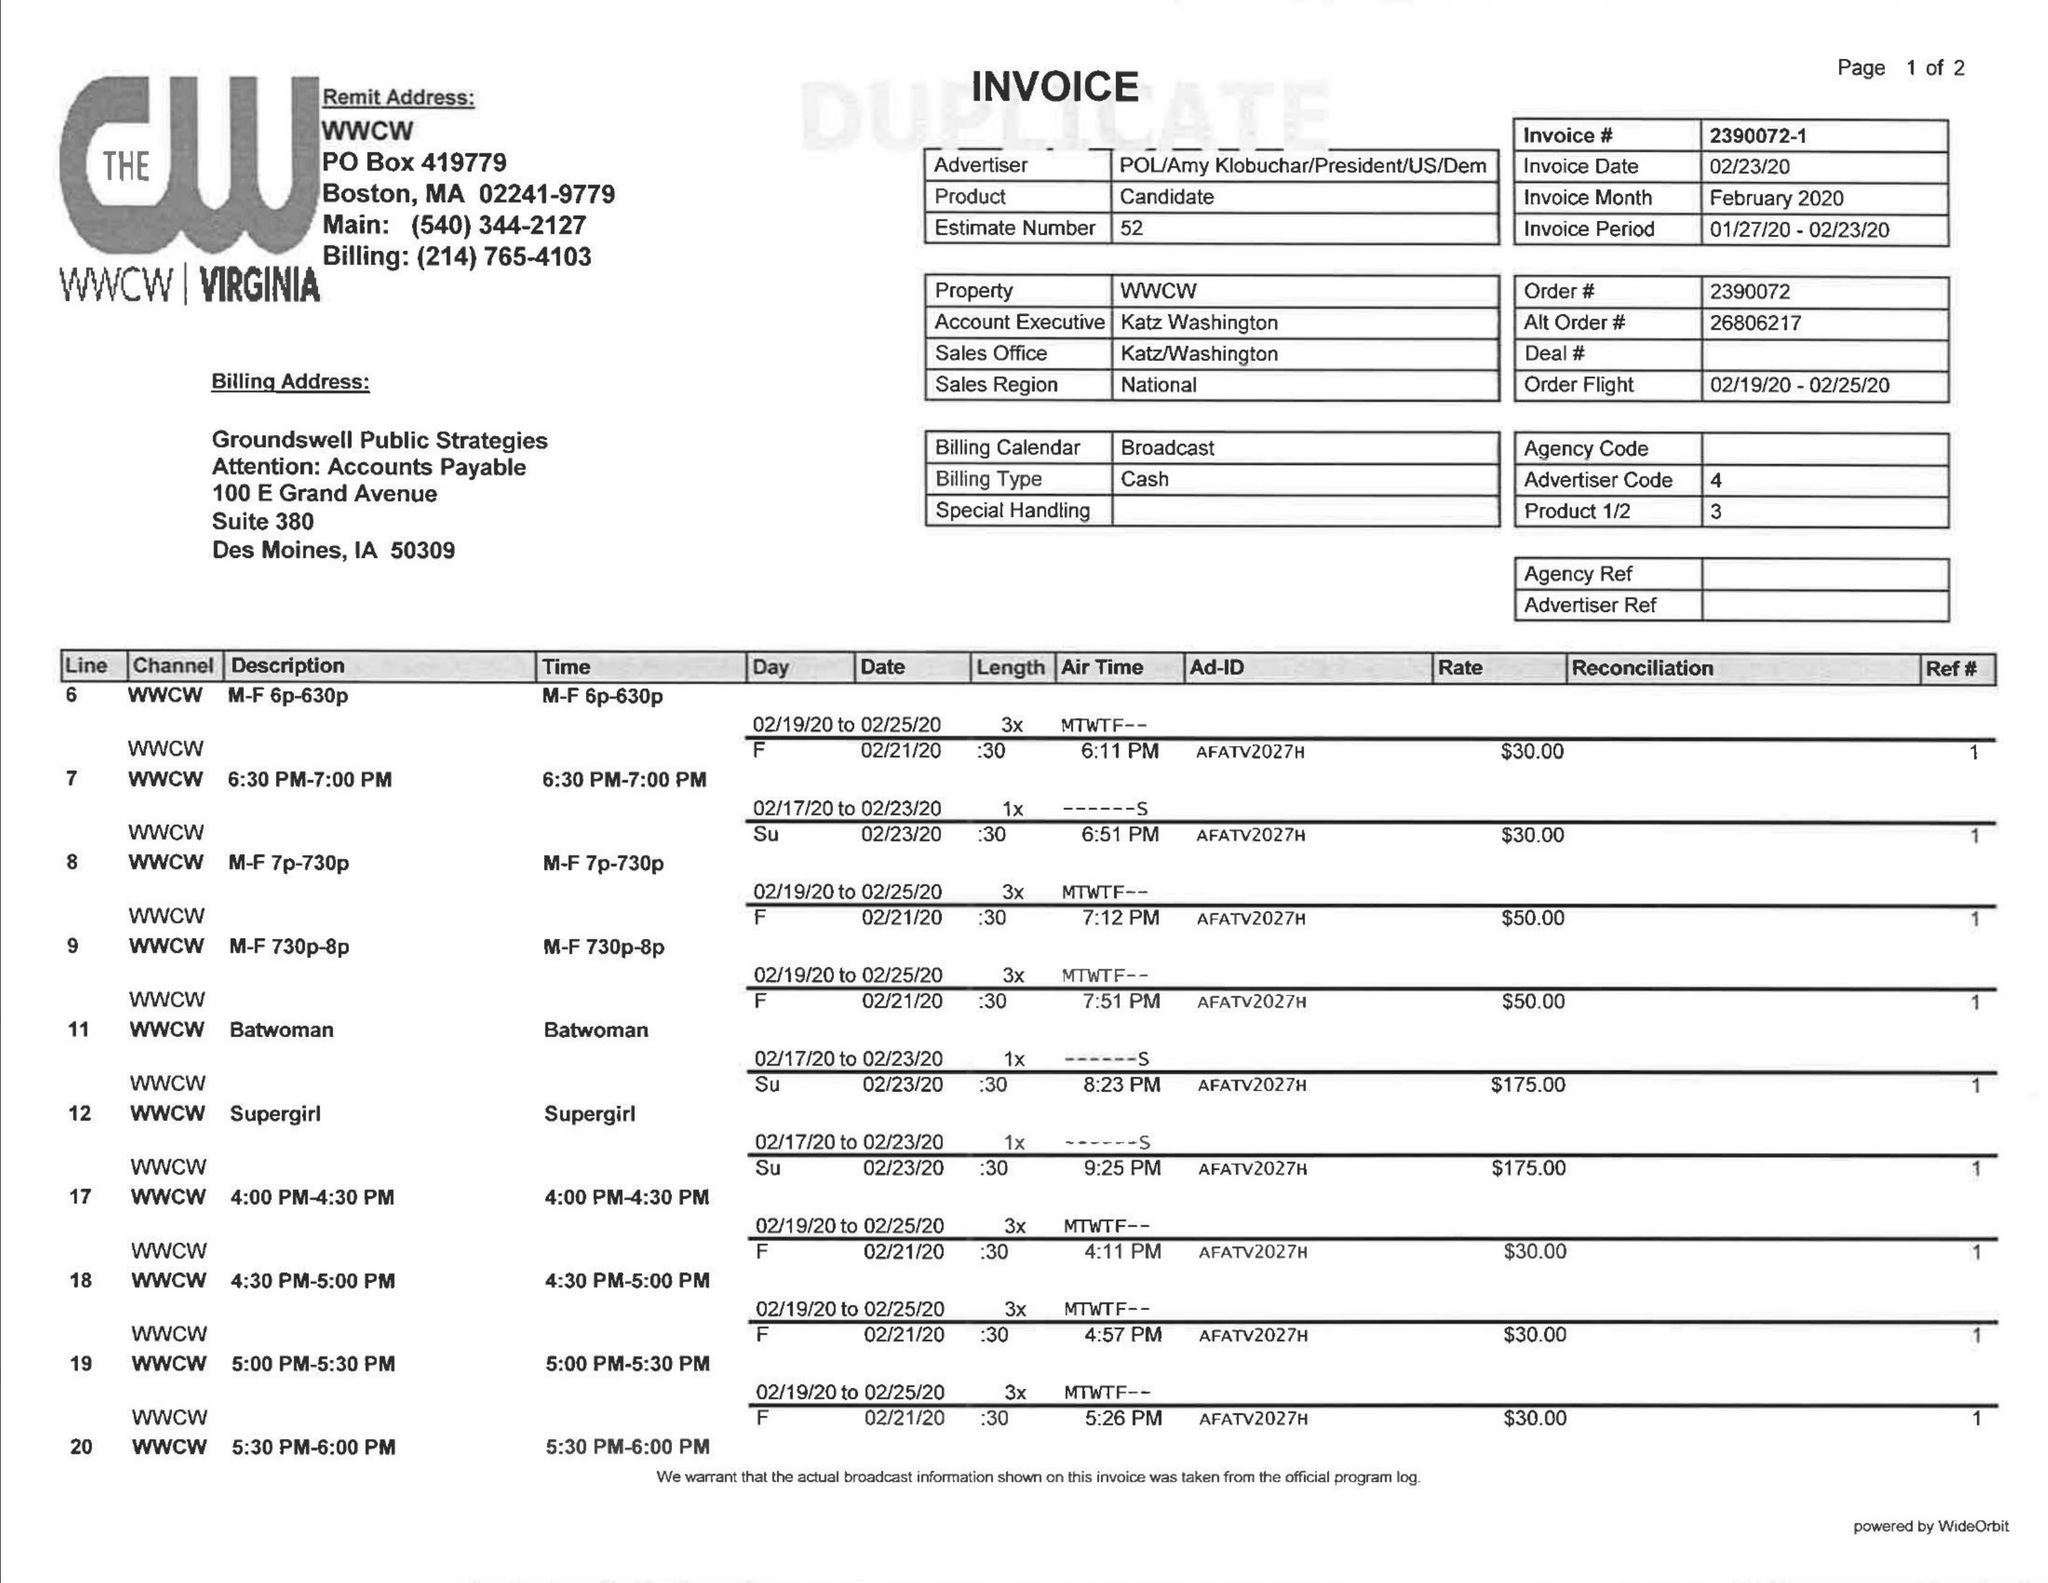What is the value for the gross_amount?
Answer the question using a single word or phrase. 730.00 